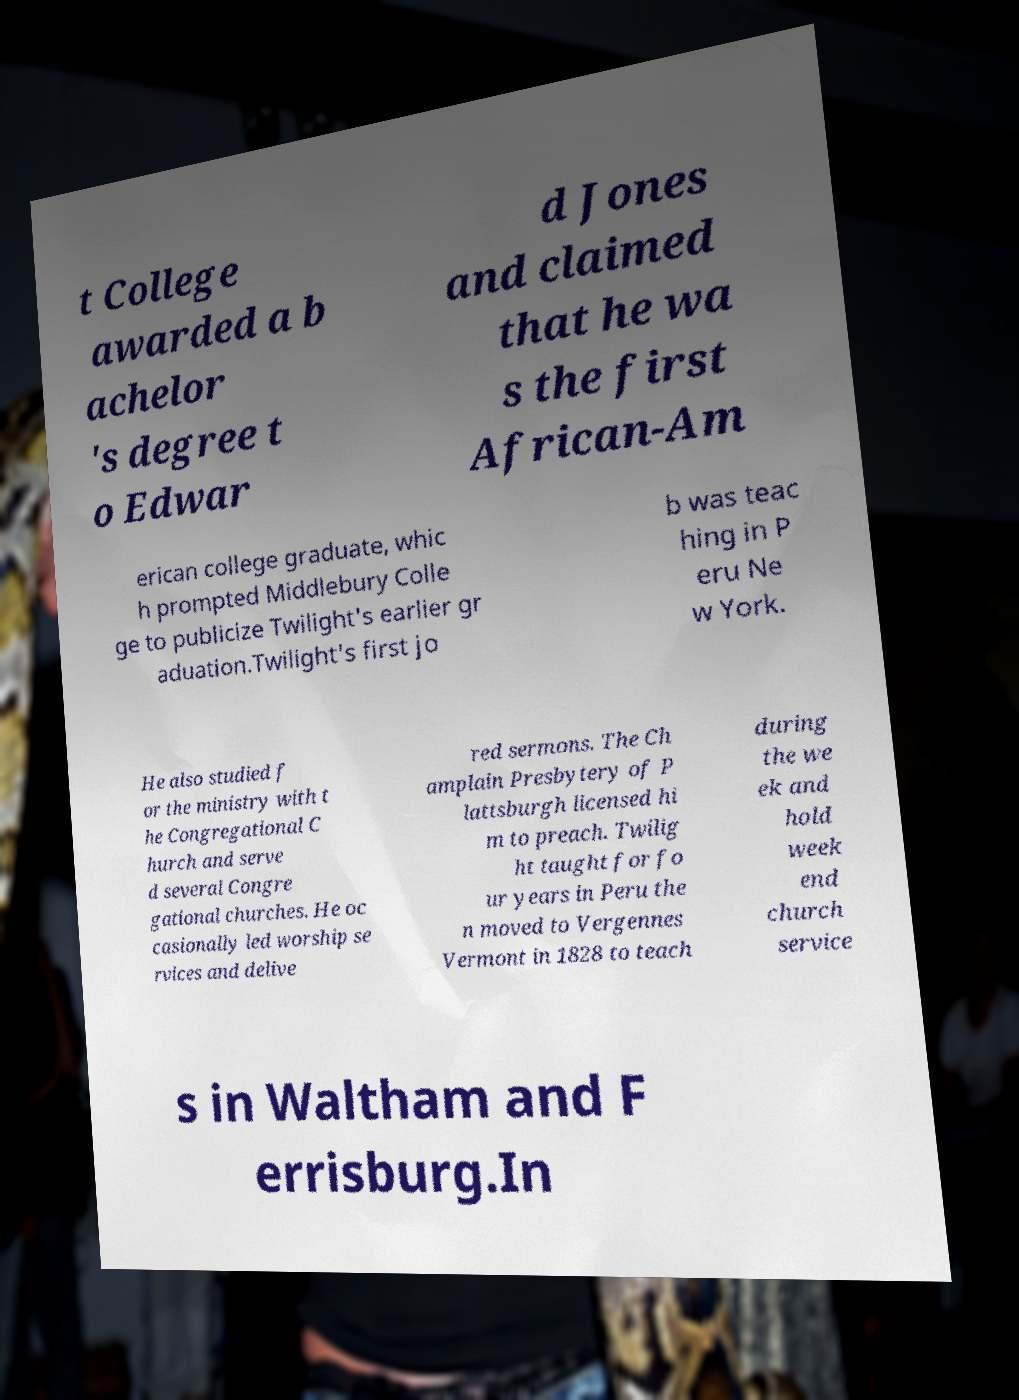For documentation purposes, I need the text within this image transcribed. Could you provide that? t College awarded a b achelor 's degree t o Edwar d Jones and claimed that he wa s the first African-Am erican college graduate, whic h prompted Middlebury Colle ge to publicize Twilight's earlier gr aduation.Twilight's first jo b was teac hing in P eru Ne w York. He also studied f or the ministry with t he Congregational C hurch and serve d several Congre gational churches. He oc casionally led worship se rvices and delive red sermons. The Ch amplain Presbytery of P lattsburgh licensed hi m to preach. Twilig ht taught for fo ur years in Peru the n moved to Vergennes Vermont in 1828 to teach during the we ek and hold week end church service s in Waltham and F errisburg.In 